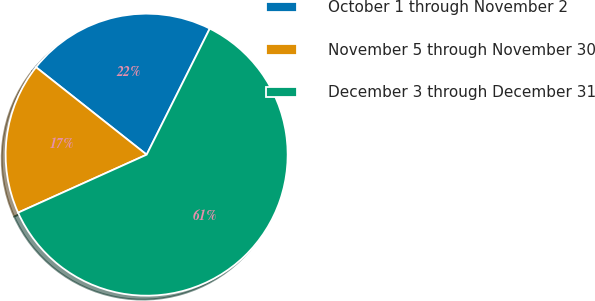Convert chart. <chart><loc_0><loc_0><loc_500><loc_500><pie_chart><fcel>October 1 through November 2<fcel>November 5 through November 30<fcel>December 3 through December 31<nl><fcel>21.74%<fcel>17.39%<fcel>60.87%<nl></chart> 